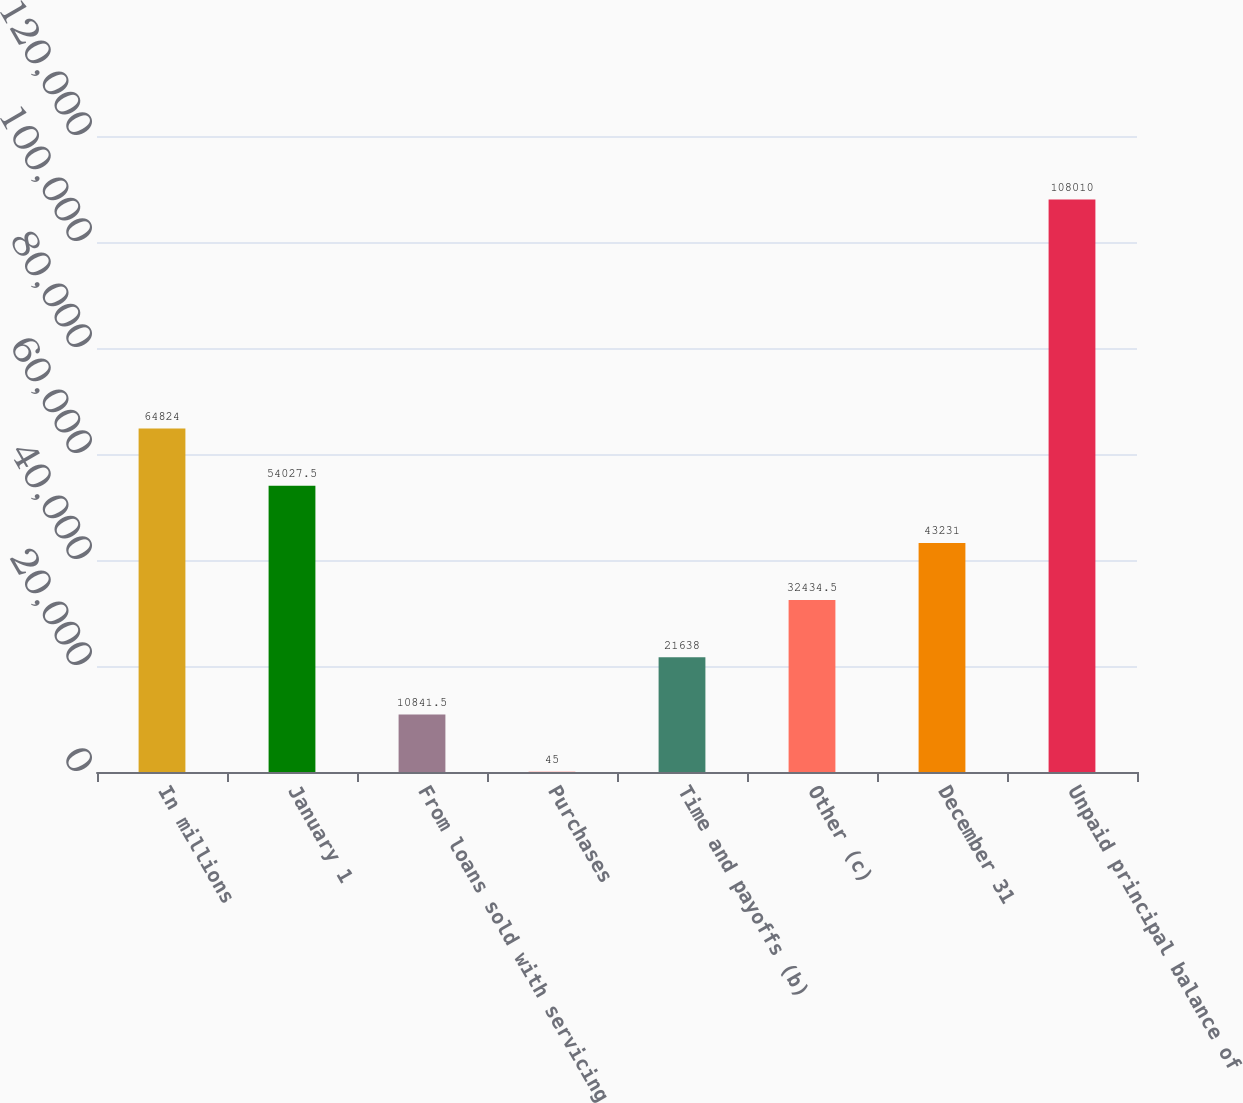Convert chart to OTSL. <chart><loc_0><loc_0><loc_500><loc_500><bar_chart><fcel>In millions<fcel>January 1<fcel>From loans sold with servicing<fcel>Purchases<fcel>Time and payoffs (b)<fcel>Other (c)<fcel>December 31<fcel>Unpaid principal balance of<nl><fcel>64824<fcel>54027.5<fcel>10841.5<fcel>45<fcel>21638<fcel>32434.5<fcel>43231<fcel>108010<nl></chart> 